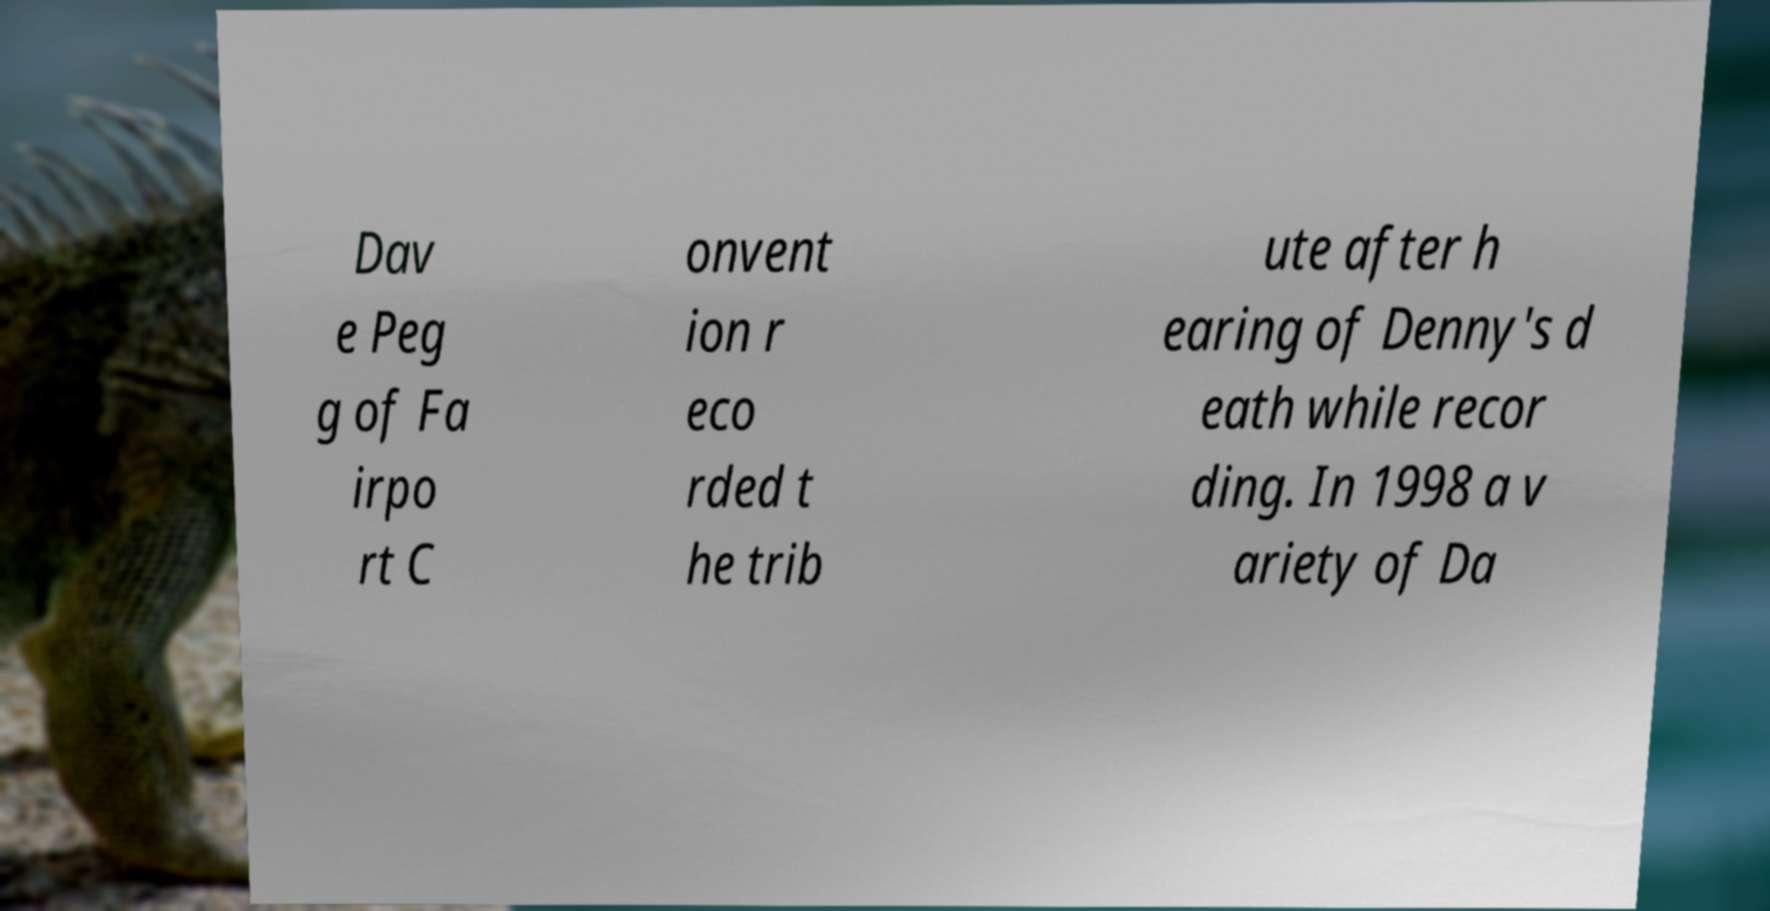Please read and relay the text visible in this image. What does it say? Dav e Peg g of Fa irpo rt C onvent ion r eco rded t he trib ute after h earing of Denny's d eath while recor ding. In 1998 a v ariety of Da 